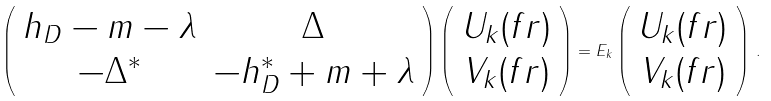Convert formula to latex. <formula><loc_0><loc_0><loc_500><loc_500>\left ( \begin{array} { c c } h _ { D } - m - \lambda & \Delta \\ - \Delta ^ { * } & - h _ { D } ^ { * } + m + \lambda \end{array} \right ) \left ( \begin{array} { c } U _ { k } ( f { r } ) \\ V _ { k } ( f { r } ) \end{array} \right ) = E _ { k } \left ( \begin{array} { c } U _ { k } ( f { r } ) \\ V _ { k } ( f { r } ) \end{array} \right ) \, .</formula> 